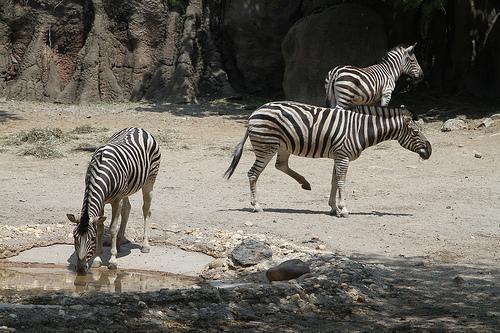How many zebras are there?
Give a very brief answer. 3. How many zebras are in the picture?
Give a very brief answer. 3. How many zebra feet are not on the ground?
Give a very brief answer. 1. How many feet are touching the ground of the middle zebra?
Give a very brief answer. 3. How many animals are drinking from the puddle?
Give a very brief answer. 1. 